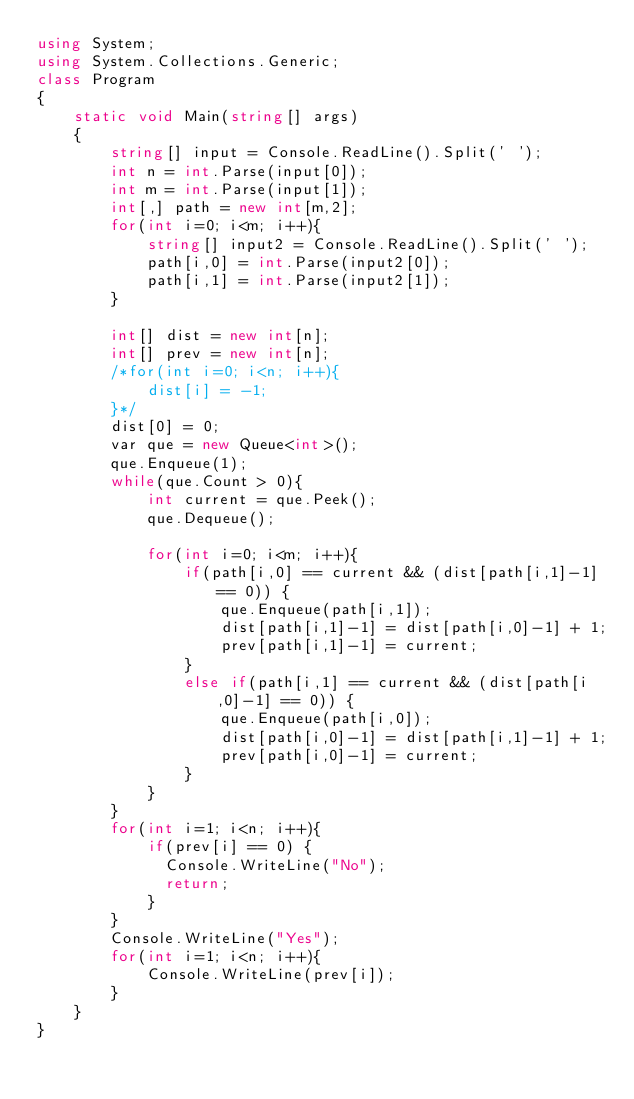<code> <loc_0><loc_0><loc_500><loc_500><_C#_>using System;
using System.Collections.Generic;
class Program
{
	static void Main(string[] args)
	{
        string[] input = Console.ReadLine().Split(' ');
        int n = int.Parse(input[0]);
        int m = int.Parse(input[1]);
        int[,] path = new int[m,2];
        for(int i=0; i<m; i++){
            string[] input2 = Console.ReadLine().Split(' ');
            path[i,0] = int.Parse(input2[0]);
            path[i,1] = int.Parse(input2[1]);
        }

        int[] dist = new int[n];
        int[] prev = new int[n];
        /*for(int i=0; i<n; i++){
            dist[i] = -1;
        }*/
        dist[0] = 0;
        var que = new Queue<int>();
        que.Enqueue(1);
        while(que.Count > 0){
            int current = que.Peek();
            que.Dequeue();

            for(int i=0; i<m; i++){
                if(path[i,0] == current && (dist[path[i,1]-1] == 0)) {
                    que.Enqueue(path[i,1]);
                    dist[path[i,1]-1] = dist[path[i,0]-1] + 1; 
                    prev[path[i,1]-1] = current;
                }
                else if(path[i,1] == current && (dist[path[i,0]-1] == 0)) {
                    que.Enqueue(path[i,0]);
                    dist[path[i,0]-1] = dist[path[i,1]-1] + 1;
                    prev[path[i,0]-1] = current;
                }
            }
        }
        for(int i=1; i<n; i++){
            if(prev[i] == 0) {
              Console.WriteLine("No");
              return;
            }
        }
        Console.WriteLine("Yes");
        for(int i=1; i<n; i++){
            Console.WriteLine(prev[i]);
        }
	}   
}</code> 